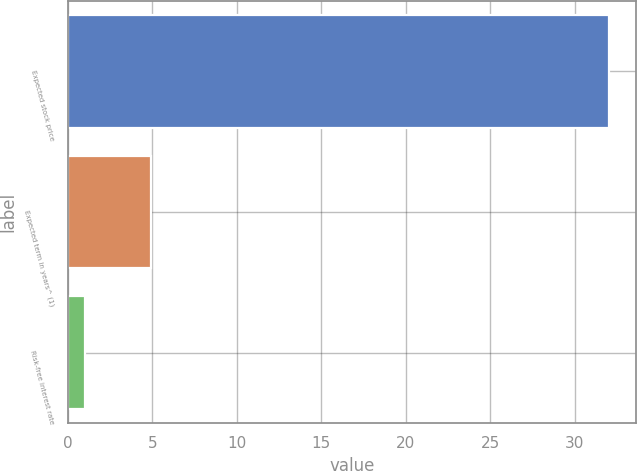<chart> <loc_0><loc_0><loc_500><loc_500><bar_chart><fcel>Expected stock price<fcel>Expected term in years^ (1)<fcel>Risk-free interest rate<nl><fcel>32<fcel>4.9<fcel>1<nl></chart> 